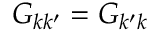Convert formula to latex. <formula><loc_0><loc_0><loc_500><loc_500>G _ { k k ^ { \prime } } = G _ { k ^ { \prime } k }</formula> 